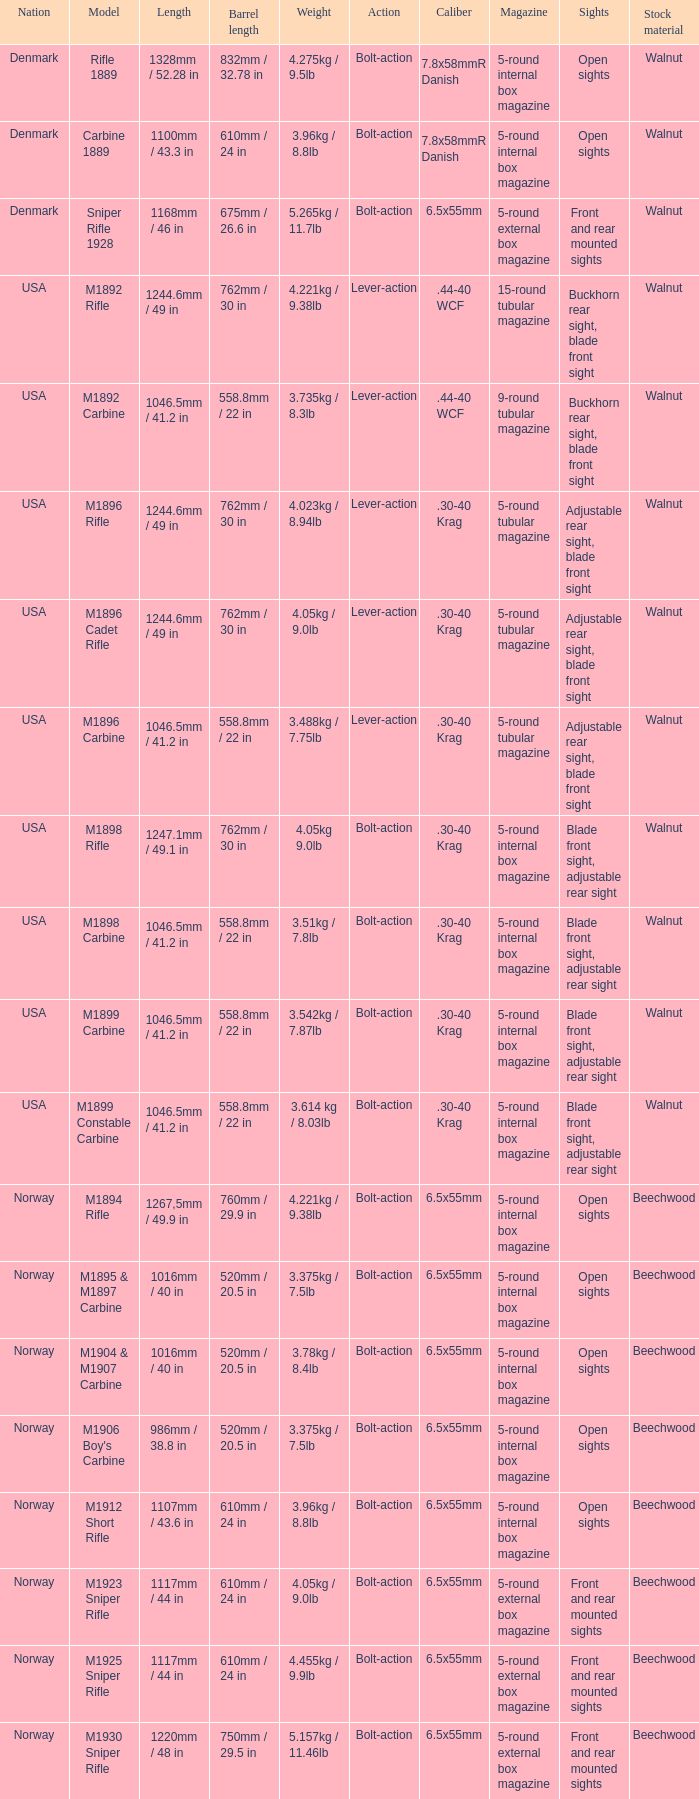Can you give me this table as a dict? {'header': ['Nation', 'Model', 'Length', 'Barrel length', 'Weight', 'Action', 'Caliber', 'Magazine', 'Sights', 'Stock material'], 'rows': [['Denmark', 'Rifle 1889', '1328mm / 52.28 in', '832mm / 32.78 in', '4.275kg / 9.5lb', 'Bolt-action', '7.8x58mmR Danish', '5-round internal box magazine', 'Open sights', 'Walnut'], ['Denmark', 'Carbine 1889', '1100mm / 43.3 in', '610mm / 24 in', '3.96kg / 8.8lb', 'Bolt-action', '7.8x58mmR Danish', '5-round internal box magazine', 'Open sights', 'Walnut'], ['Denmark', 'Sniper Rifle 1928', '1168mm / 46 in', '675mm / 26.6 in', '5.265kg / 11.7lb', 'Bolt-action', '6.5x55mm', '5-round external box magazine', 'Front and rear mounted sights', 'Walnut'], ['USA', 'M1892 Rifle', '1244.6mm / 49 in', '762mm / 30 in', '4.221kg / 9.38lb', 'Lever-action', '.44-40 WCF', '15-round tubular magazine', 'Buckhorn rear sight, blade front sight', 'Walnut'], ['USA', 'M1892 Carbine', '1046.5mm / 41.2 in', '558.8mm / 22 in', '3.735kg / 8.3lb', 'Lever-action', '.44-40 WCF', '9-round tubular magazine', 'Buckhorn rear sight, blade front sight', 'Walnut'], ['USA', 'M1896 Rifle', '1244.6mm / 49 in', '762mm / 30 in', '4.023kg / 8.94lb', 'Lever-action', '.30-40 Krag', '5-round tubular magazine', 'Adjustable rear sight, blade front sight', 'Walnut'], ['USA', 'M1896 Cadet Rifle', '1244.6mm / 49 in', '762mm / 30 in', '4.05kg / 9.0lb', 'Lever-action', '.30-40 Krag', '5-round tubular magazine', 'Adjustable rear sight, blade front sight', 'Walnut'], ['USA', 'M1896 Carbine', '1046.5mm / 41.2 in', '558.8mm / 22 in', '3.488kg / 7.75lb', 'Lever-action', '.30-40 Krag', '5-round tubular magazine', 'Adjustable rear sight, blade front sight', 'Walnut'], ['USA', 'M1898 Rifle', '1247.1mm / 49.1 in', '762mm / 30 in', '4.05kg 9.0lb', 'Bolt-action', '.30-40 Krag', '5-round internal box magazine', 'Blade front sight, adjustable rear sight', 'Walnut'], ['USA', 'M1898 Carbine', '1046.5mm / 41.2 in', '558.8mm / 22 in', '3.51kg / 7.8lb', 'Bolt-action', '.30-40 Krag', '5-round internal box magazine', 'Blade front sight, adjustable rear sight', 'Walnut'], ['USA', 'M1899 Carbine', '1046.5mm / 41.2 in', '558.8mm / 22 in', '3.542kg / 7.87lb', 'Bolt-action', '.30-40 Krag', '5-round internal box magazine', 'Blade front sight, adjustable rear sight', 'Walnut'], ['USA', 'M1899 Constable Carbine', '1046.5mm / 41.2 in', '558.8mm / 22 in', '3.614 kg / 8.03lb', 'Bolt-action', '.30-40 Krag', '5-round internal box magazine', 'Blade front sight, adjustable rear sight', 'Walnut'], ['Norway', 'M1894 Rifle', '1267,5mm / 49.9 in', '760mm / 29.9 in', '4.221kg / 9.38lb', 'Bolt-action', '6.5x55mm', '5-round internal box magazine', 'Open sights', 'Beechwood'], ['Norway', 'M1895 & M1897 Carbine', '1016mm / 40 in', '520mm / 20.5 in', '3.375kg / 7.5lb', 'Bolt-action', '6.5x55mm', '5-round internal box magazine', 'Open sights', 'Beechwood'], ['Norway', 'M1904 & M1907 Carbine', '1016mm / 40 in', '520mm / 20.5 in', '3.78kg / 8.4lb', 'Bolt-action', '6.5x55mm', '5-round internal box magazine', 'Open sights', 'Beechwood'], ['Norway', "M1906 Boy's Carbine", '986mm / 38.8 in', '520mm / 20.5 in', '3.375kg / 7.5lb', 'Bolt-action', '6.5x55mm', '5-round internal box magazine', 'Open sights', 'Beechwood'], ['Norway', 'M1912 Short Rifle', '1107mm / 43.6 in', '610mm / 24 in', '3.96kg / 8.8lb', 'Bolt-action', '6.5x55mm', '5-round internal box magazine', 'Open sights', 'Beechwood'], ['Norway', 'M1923 Sniper Rifle', '1117mm / 44 in', '610mm / 24 in', '4.05kg / 9.0lb', 'Bolt-action', '6.5x55mm', '5-round external box magazine', 'Front and rear mounted sights', 'Beechwood'], ['Norway', 'M1925 Sniper Rifle', '1117mm / 44 in', '610mm / 24 in', '4.455kg / 9.9lb', 'Bolt-action', '6.5x55mm', '5-round external box magazine', 'Front and rear mounted sights', 'Beechwood'], ['Norway', 'M1930 Sniper Rifle', '1220mm / 48 in', '750mm / 29.5 in', '5.157kg / 11.46lb', 'Bolt-action', '6.5x55mm', '5-round external box magazine', 'Front and rear mounted sights', 'Beechwood']]} What is Nation, when Model is M1895 & M1897 Carbine? Norway. 